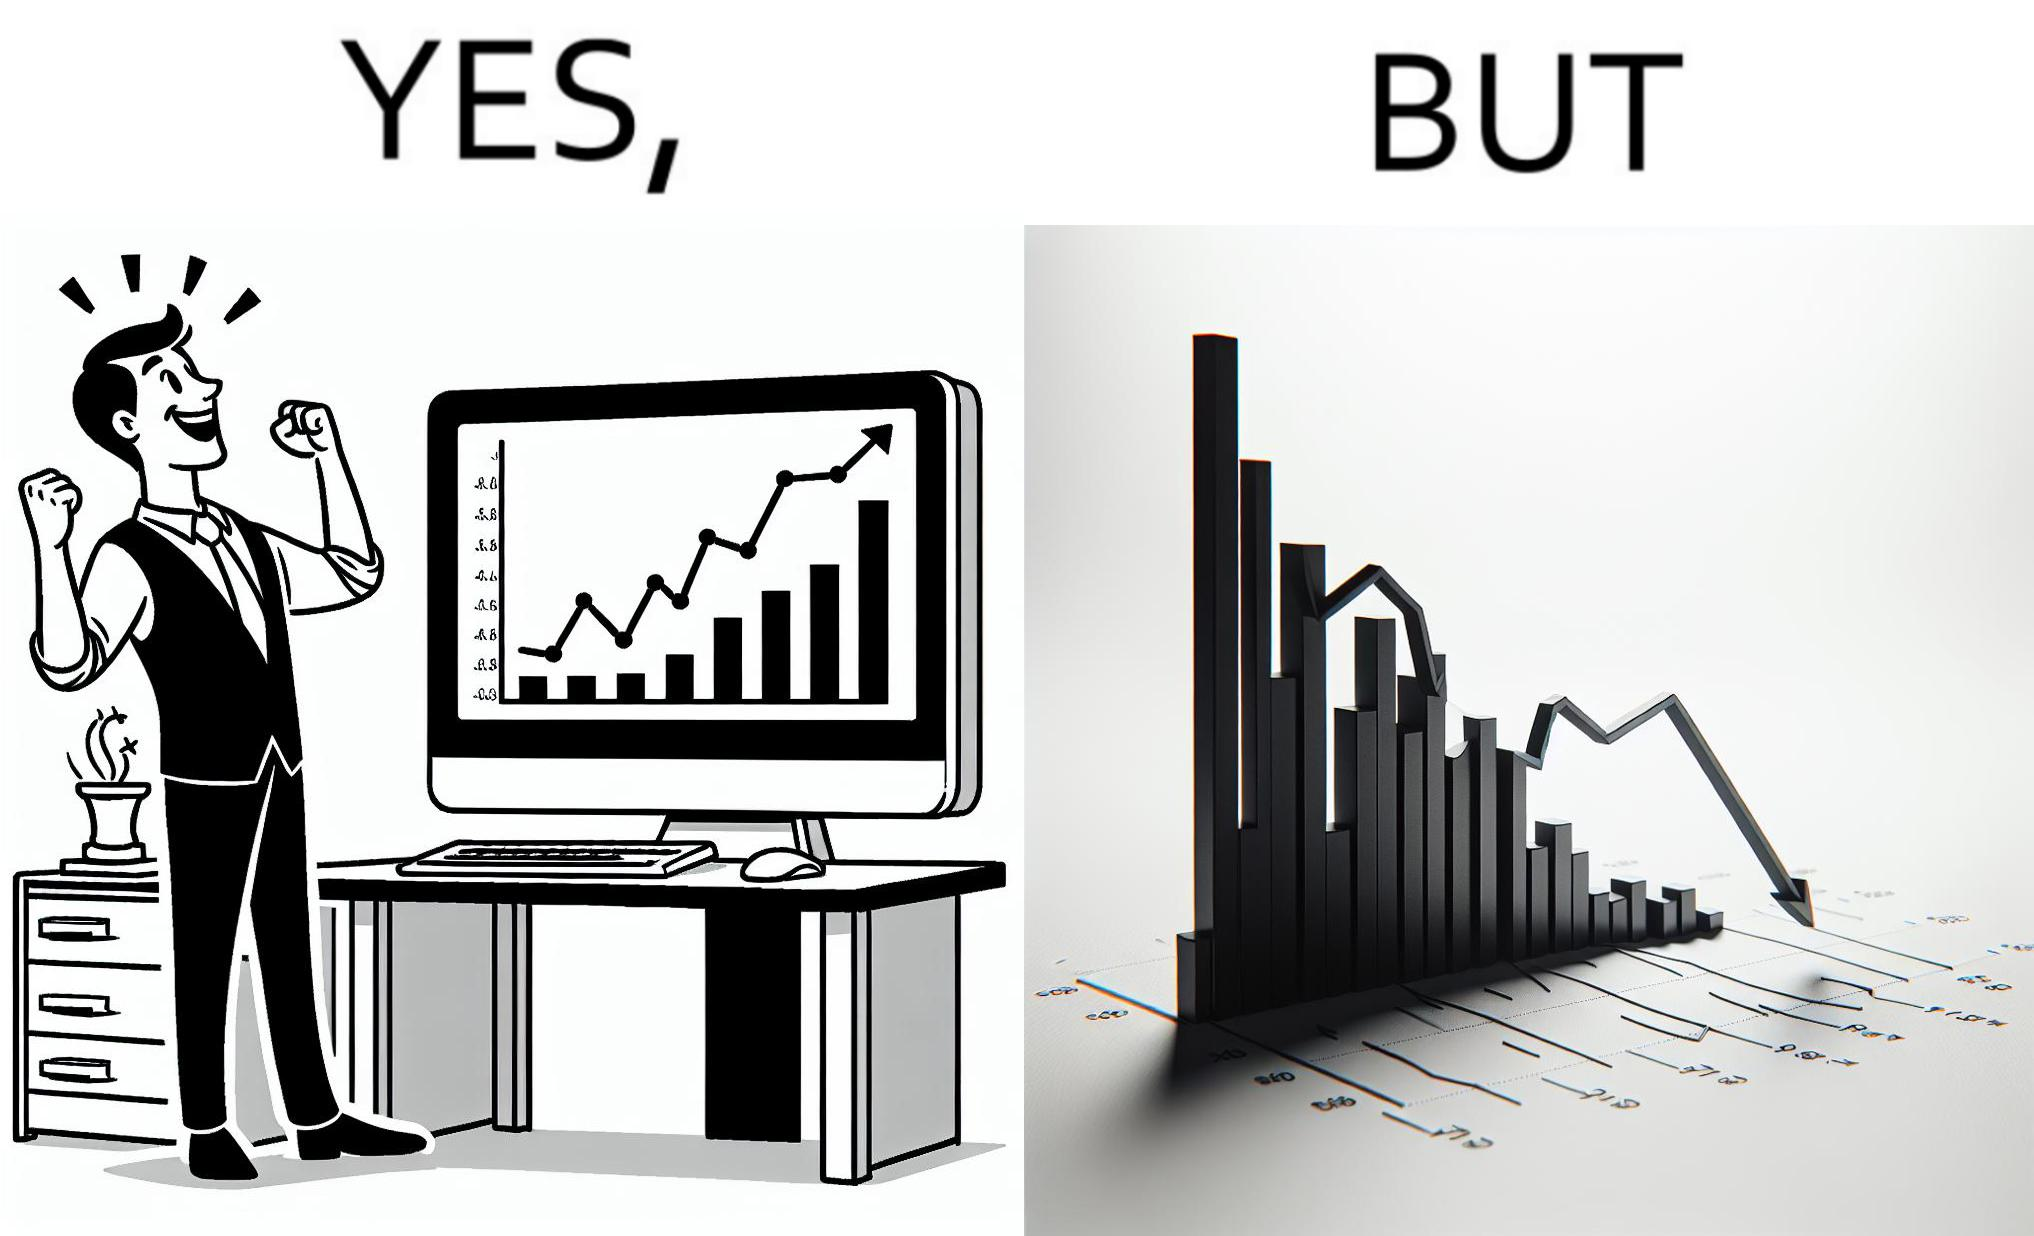What is the satirical meaning behind this image? The image is ironic, because a person is seen feeling proud over the profit earned over his investment but the right image shows the whole story how only a small part of his investment journey is shown and the other loss part is ignored 